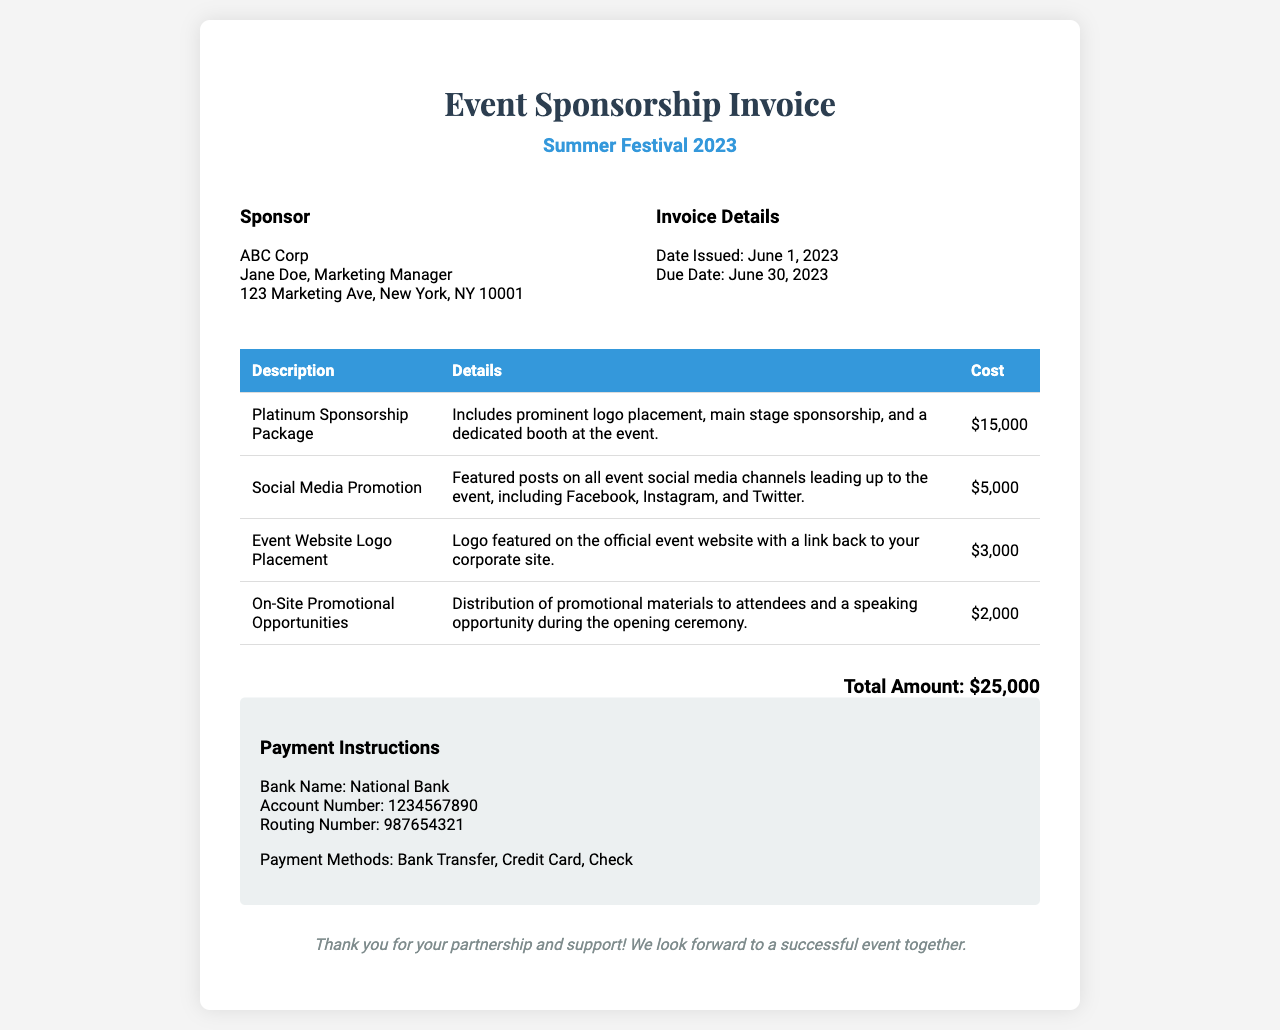what is the event name? The event name is presented prominently in the header section of the document.
Answer: Summer Festival 2023 who is the sponsor? The sponsor's details are listed in the sponsor info section.
Answer: ABC Corp what is the total amount due? The total amount is summarized at the end of the document.
Answer: $25,000 when was the invoice issued? The date issued is mentioned in the invoice details section.
Answer: June 1, 2023 what is included in the Platinum Sponsorship Package? The details of the package are specified in the corresponding row of the table.
Answer: Prominent logo placement, main stage sponsorship, and a dedicated booth at the event how much does Social Media Promotion cost? The cost is provided in the table next to the description of the service.
Answer: $5,000 what payment methods are available? The payment instructions section lists the acceptable methods for payment.
Answer: Bank Transfer, Credit Card, Check what is the due date for the payment? The due date is identified in the invoice details section.
Answer: June 30, 2023 what are the on-site promotional opportunities? The details are included in the corresponding row of the table for that service.
Answer: Distribution of promotional materials to attendees and a speaking opportunity during the opening ceremony 